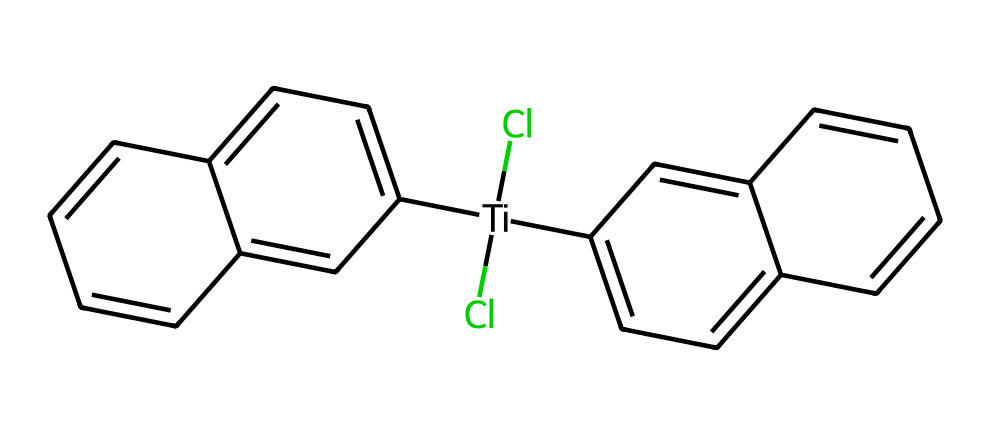What is the central metal atom in this organometallic compound? The SMILES representation indicates that Titanium (Ti) is the central metal atom, as it is the first element listed and surrounded by other substituents.
Answer: Titanium How many chlorine atoms are present in titanocene dichloride? The structural formula shows Cl appearing twice, indicating there are two chlorine atoms bonded to the titanium.
Answer: 2 What type of bonding is primarily observed between titanium and chlorine in this compound? The connection between titanium and chlorine is through coordinate covalent bonds, where electrons are shared between titanium and chlorine atoms, typical of organometallic compounds.
Answer: Coordinate covalent bonds How many aromatic rings are present in the structure of titanocene dichloride? By examining the cyclic structure, we can see there are two distinct aromatic rings attached to the titanium atom, which is a feature of the compound's structure.
Answer: 2 What functional groups are observed in titanocene dichloride? The presence of the chlorine atoms signifies the functional group as halogens, specifically dichloro, and the cationic structure suggests other parent aryl groups as functional attachments.
Answer: Dichloro Which property of titanocene dichloride makes it relevant in cancer research? Titanocene dichloride’s ability to intercalate with DNA, facilitated by its organometallic structure, allows it to inhibit cell division, making it a potential anti-cancer agent.
Answer: Anti-cancer agent What is the overall shape around the titanium center in this compound? The coordination of the titanium atom with the attached chlorine and aromatic rings results in a distorted octahedral geometry due to steric hindrance from the bulky aromatic groups.
Answer: Distorted octahedral 